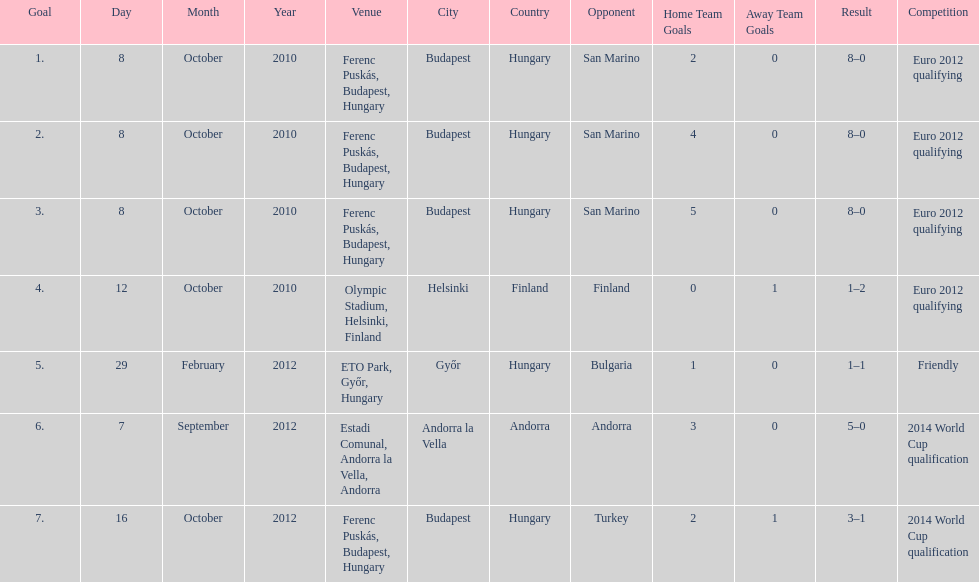What is the number of goals ádám szalai made against san marino in 2010? 3. 